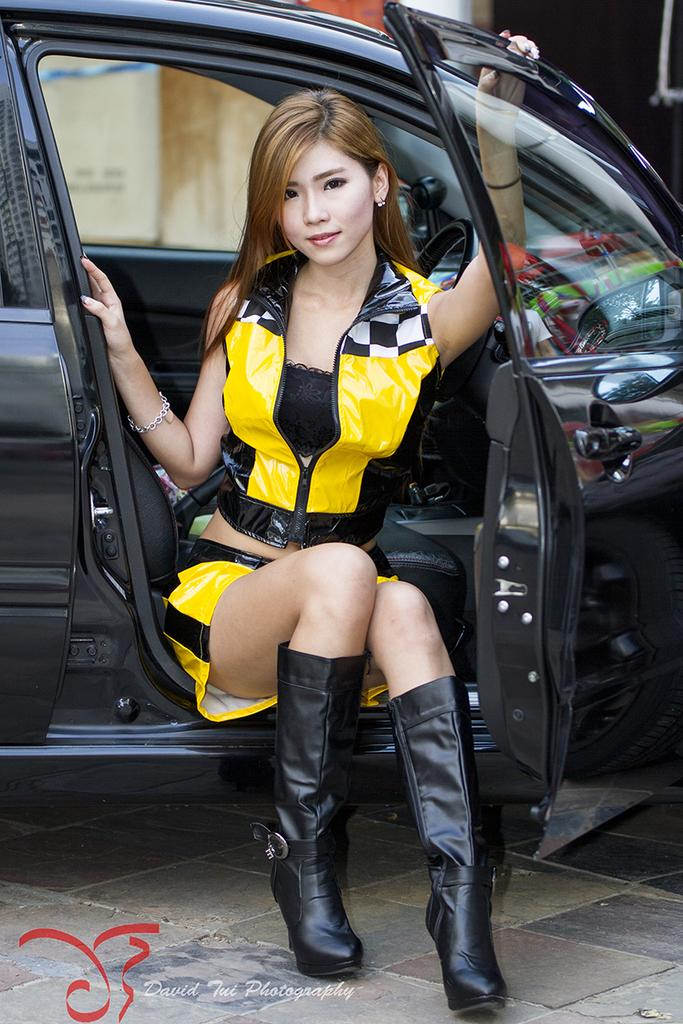Who is the main subject in the image? There is a woman in the image. What is the woman wearing? The woman is wearing a yellow dress. What is the woman doing in the image? The woman is sitting in a car. How is the woman interacting with the car? The woman is holding the car door with one of her hands. What type of pain is the woman experiencing in the image? There is no indication in the image that the woman is experiencing any pain. 